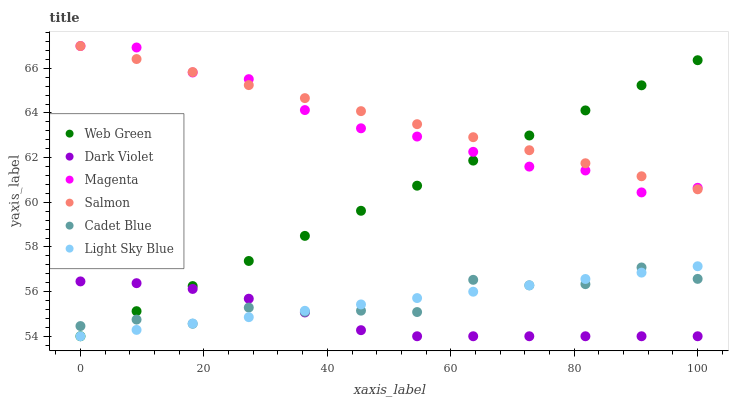Does Dark Violet have the minimum area under the curve?
Answer yes or no. Yes. Does Salmon have the maximum area under the curve?
Answer yes or no. Yes. Does Salmon have the minimum area under the curve?
Answer yes or no. No. Does Dark Violet have the maximum area under the curve?
Answer yes or no. No. Is Light Sky Blue the smoothest?
Answer yes or no. Yes. Is Cadet Blue the roughest?
Answer yes or no. Yes. Is Salmon the smoothest?
Answer yes or no. No. Is Salmon the roughest?
Answer yes or no. No. Does Dark Violet have the lowest value?
Answer yes or no. Yes. Does Salmon have the lowest value?
Answer yes or no. No. Does Magenta have the highest value?
Answer yes or no. Yes. Does Dark Violet have the highest value?
Answer yes or no. No. Is Dark Violet less than Salmon?
Answer yes or no. Yes. Is Salmon greater than Dark Violet?
Answer yes or no. Yes. Does Web Green intersect Dark Violet?
Answer yes or no. Yes. Is Web Green less than Dark Violet?
Answer yes or no. No. Is Web Green greater than Dark Violet?
Answer yes or no. No. Does Dark Violet intersect Salmon?
Answer yes or no. No. 